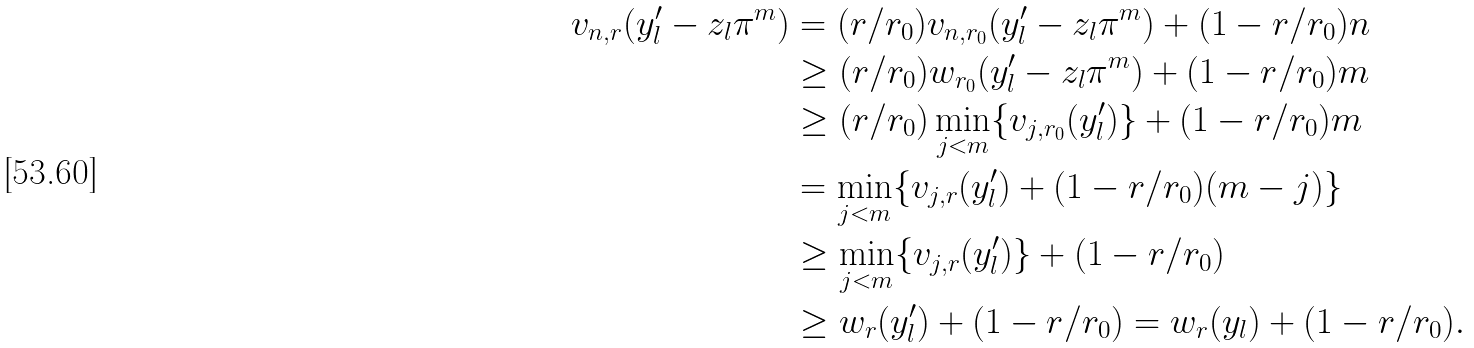Convert formula to latex. <formula><loc_0><loc_0><loc_500><loc_500>v _ { n , r } ( y ^ { \prime } _ { l } - z _ { l } \pi ^ { m } ) & = ( r / r _ { 0 } ) v _ { n , r _ { 0 } } ( y ^ { \prime } _ { l } - z _ { l } \pi ^ { m } ) + ( 1 - r / r _ { 0 } ) n \\ & \geq ( r / r _ { 0 } ) w _ { r _ { 0 } } ( y ^ { \prime } _ { l } - z _ { l } \pi ^ { m } ) + ( 1 - r / r _ { 0 } ) m \\ & \geq ( r / r _ { 0 } ) \min _ { j < m } \{ v _ { j , r _ { 0 } } ( y ^ { \prime } _ { l } ) \} + ( 1 - r / r _ { 0 } ) m \\ & = \min _ { j < m } \{ v _ { j , r } ( y ^ { \prime } _ { l } ) + ( 1 - r / r _ { 0 } ) ( m - j ) \} \\ & \geq \min _ { j < m } \{ v _ { j , r } ( y ^ { \prime } _ { l } ) \} + ( 1 - r / r _ { 0 } ) \\ & \geq w _ { r } ( y ^ { \prime } _ { l } ) + ( 1 - r / r _ { 0 } ) = w _ { r } ( y _ { l } ) + ( 1 - r / r _ { 0 } ) .</formula> 